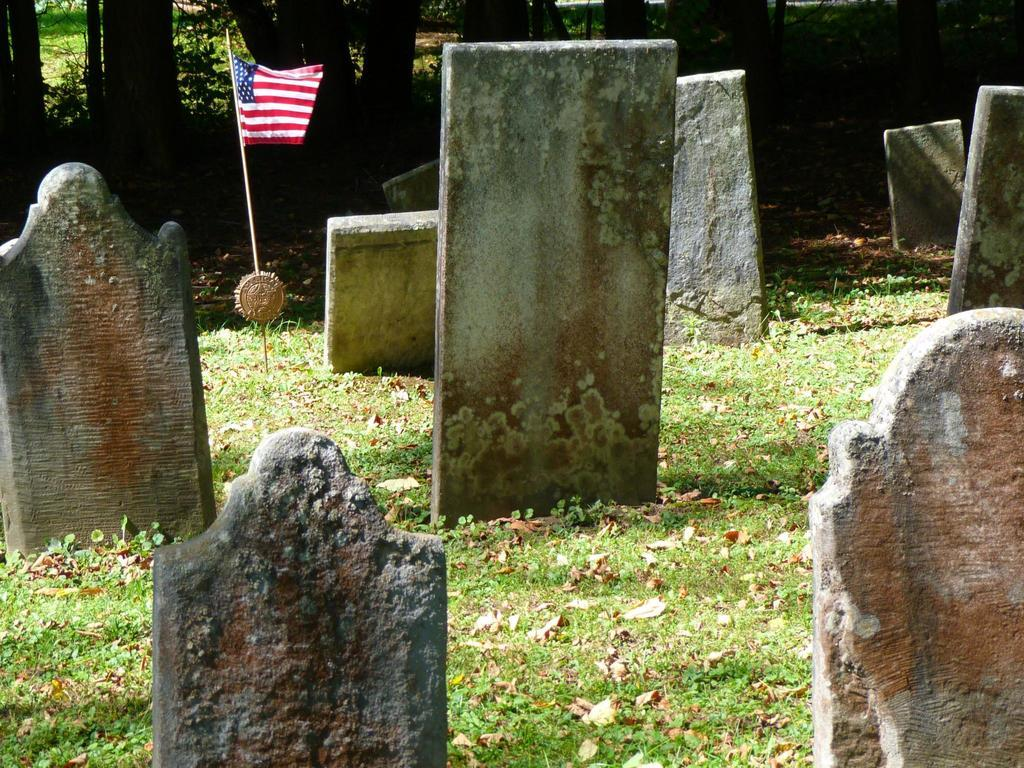What is the main subject of the picture? The main subject of the picture is a graveyard. Are there any objects or structures related to the graveyard? Yes, there is a flag with a pole in the picture. What can be seen in the background of the picture? There are trees in the background of the picture. How many boxes can be seen shaking in the power lines in the image? There are no boxes or power lines present in the image; it features a graveyard and a flag with a pole. 